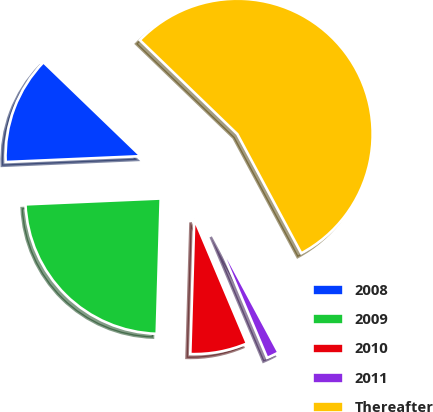<chart> <loc_0><loc_0><loc_500><loc_500><pie_chart><fcel>2008<fcel>2009<fcel>2010<fcel>2011<fcel>Thereafter<nl><fcel>12.9%<fcel>23.84%<fcel>6.83%<fcel>1.48%<fcel>54.95%<nl></chart> 